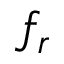<formula> <loc_0><loc_0><loc_500><loc_500>f _ { r }</formula> 